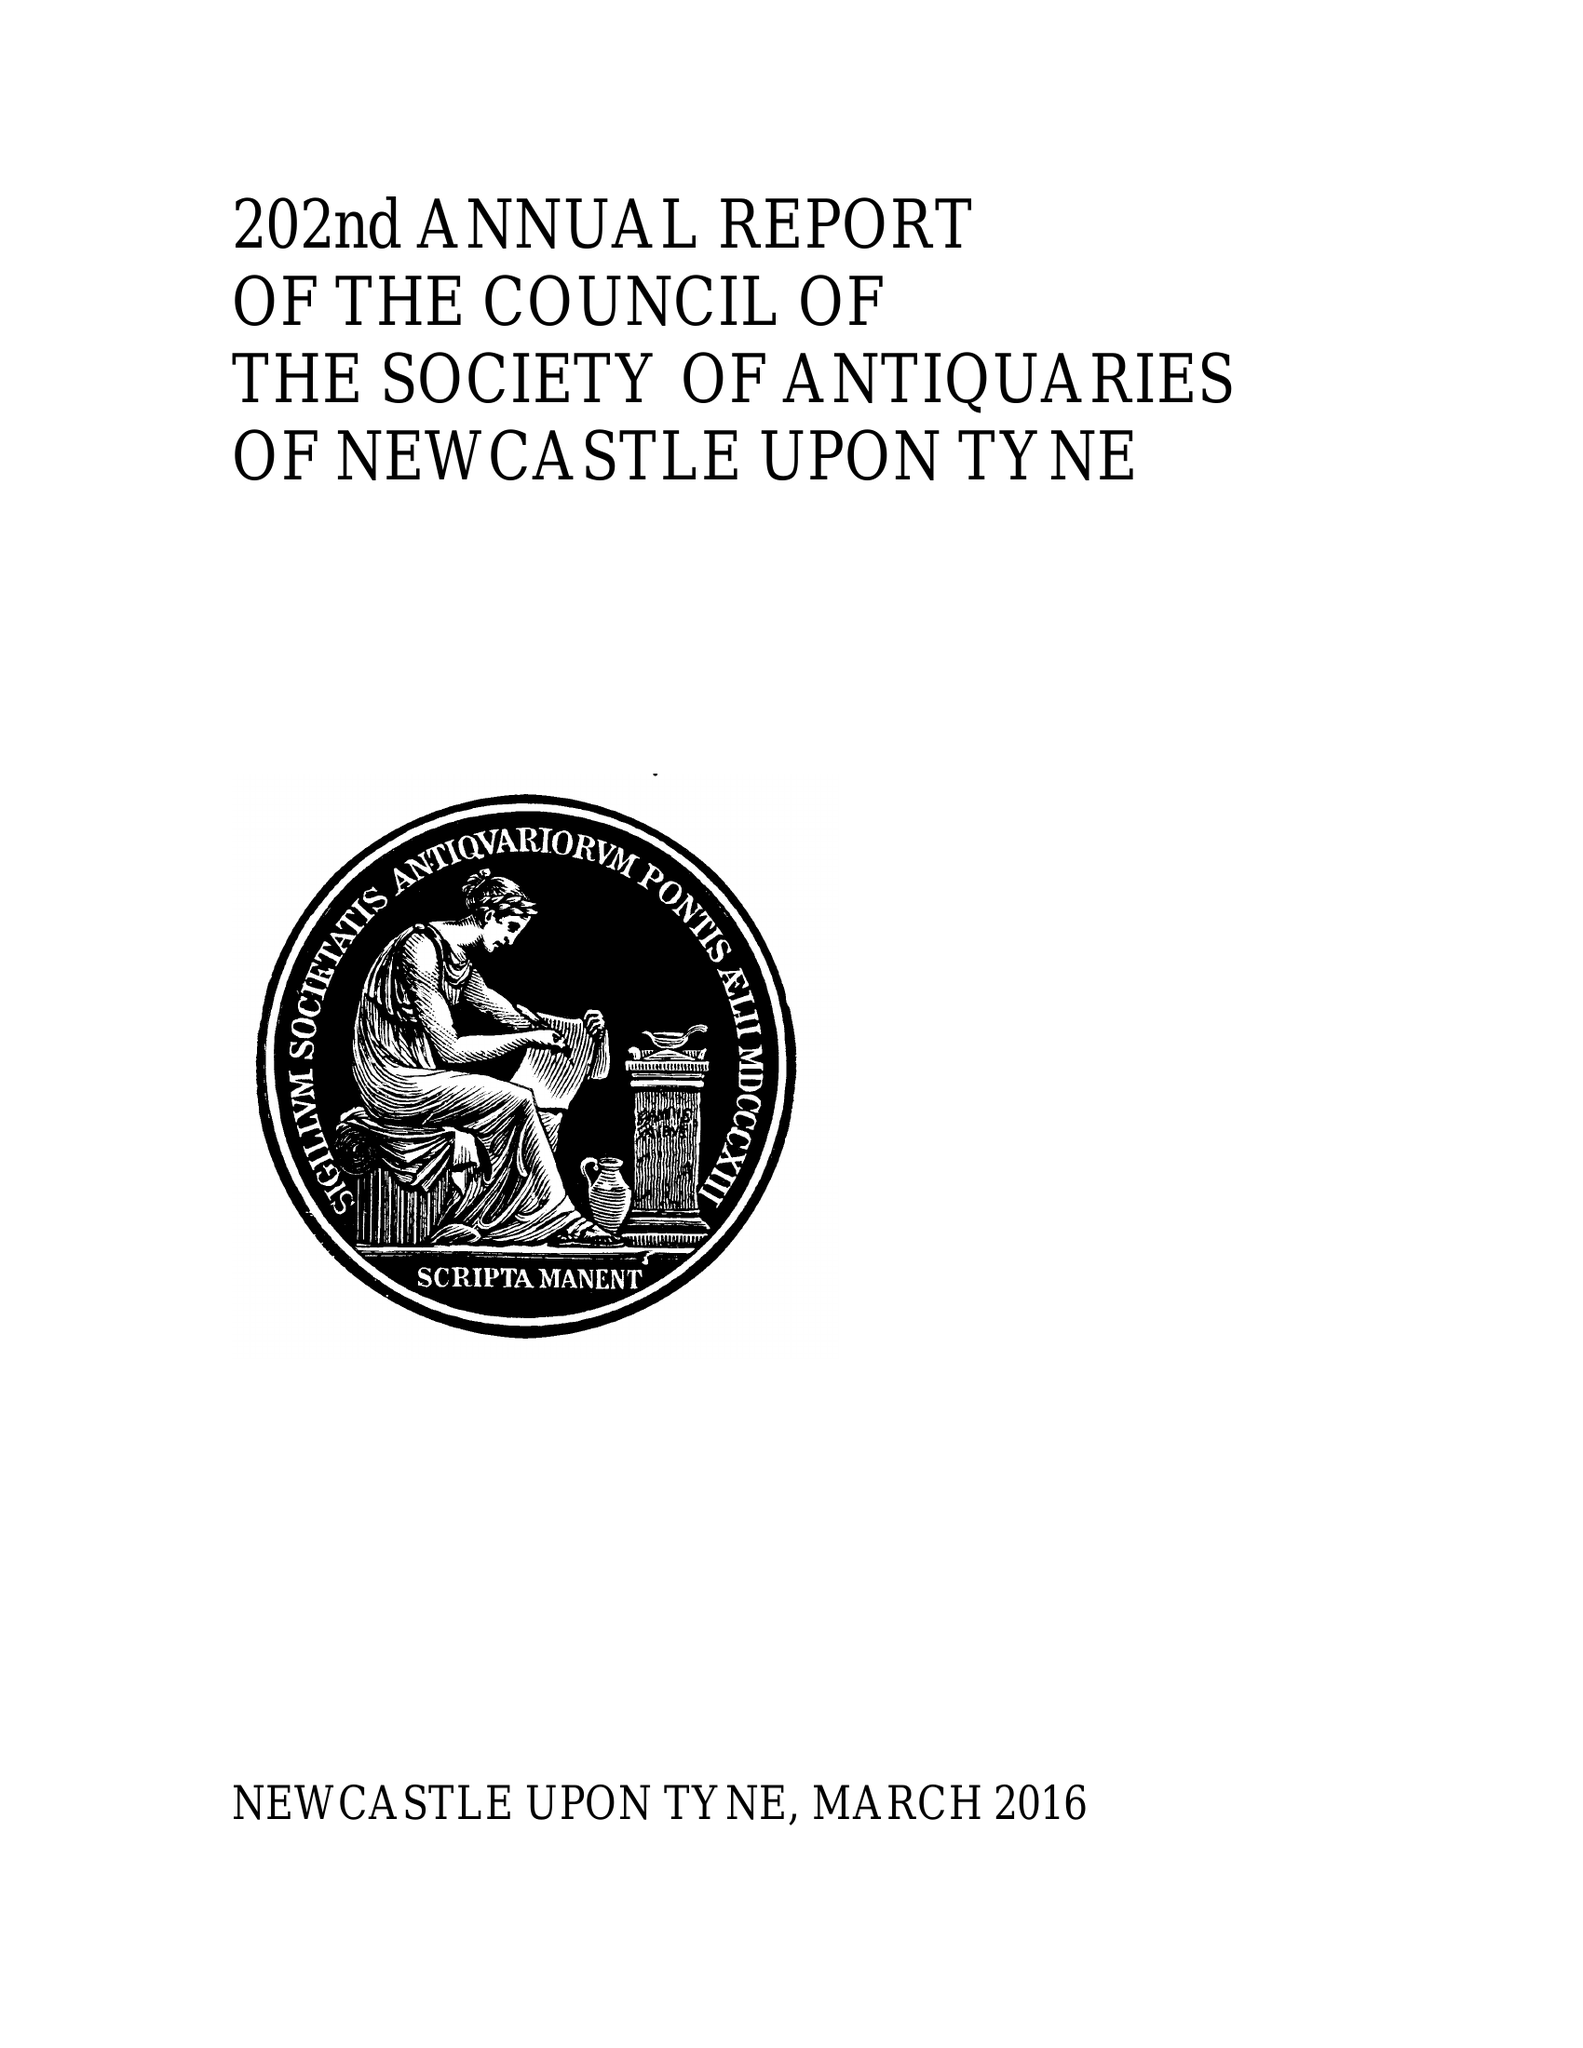What is the value for the address__postcode?
Answer the question using a single word or phrase. NE2 4PT 